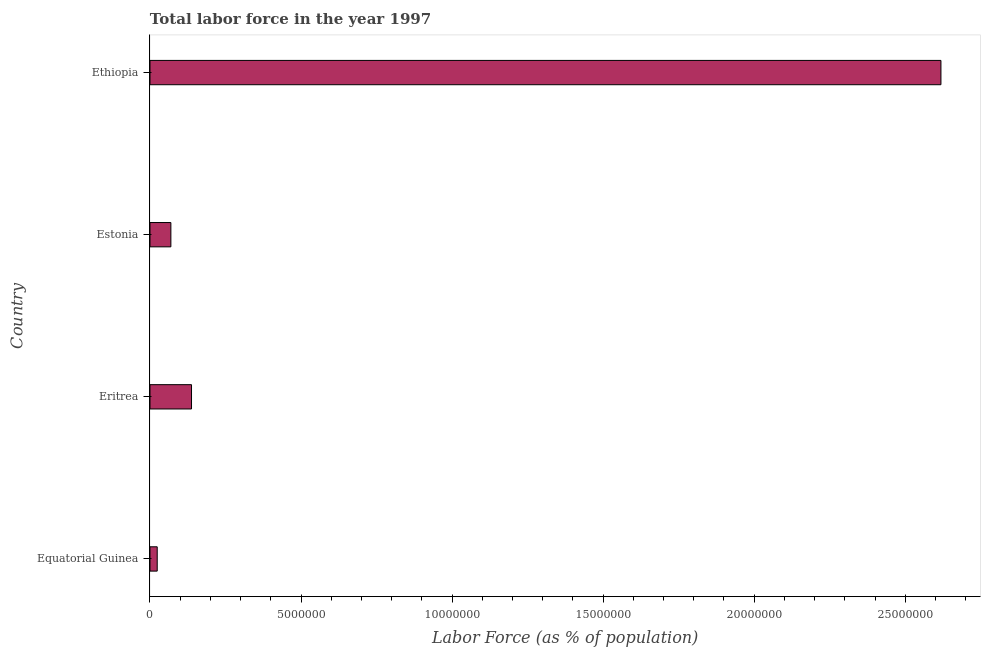Does the graph contain grids?
Ensure brevity in your answer.  No. What is the title of the graph?
Keep it short and to the point. Total labor force in the year 1997. What is the label or title of the X-axis?
Your answer should be very brief. Labor Force (as % of population). What is the label or title of the Y-axis?
Keep it short and to the point. Country. What is the total labor force in Eritrea?
Your answer should be compact. 1.37e+06. Across all countries, what is the maximum total labor force?
Ensure brevity in your answer.  2.62e+07. Across all countries, what is the minimum total labor force?
Keep it short and to the point. 2.39e+05. In which country was the total labor force maximum?
Ensure brevity in your answer.  Ethiopia. In which country was the total labor force minimum?
Offer a very short reply. Equatorial Guinea. What is the sum of the total labor force?
Provide a short and direct response. 2.85e+07. What is the difference between the total labor force in Equatorial Guinea and Estonia?
Ensure brevity in your answer.  -4.52e+05. What is the average total labor force per country?
Your answer should be compact. 7.12e+06. What is the median total labor force?
Your answer should be very brief. 1.03e+06. In how many countries, is the total labor force greater than 1000000 %?
Ensure brevity in your answer.  2. What is the ratio of the total labor force in Equatorial Guinea to that in Ethiopia?
Make the answer very short. 0.01. Is the difference between the total labor force in Equatorial Guinea and Ethiopia greater than the difference between any two countries?
Make the answer very short. Yes. What is the difference between the highest and the second highest total labor force?
Provide a succinct answer. 2.48e+07. Is the sum of the total labor force in Equatorial Guinea and Estonia greater than the maximum total labor force across all countries?
Offer a terse response. No. What is the difference between the highest and the lowest total labor force?
Your answer should be very brief. 2.59e+07. Are all the bars in the graph horizontal?
Provide a short and direct response. Yes. How many countries are there in the graph?
Give a very brief answer. 4. What is the difference between two consecutive major ticks on the X-axis?
Your answer should be compact. 5.00e+06. Are the values on the major ticks of X-axis written in scientific E-notation?
Make the answer very short. No. What is the Labor Force (as % of population) of Equatorial Guinea?
Provide a short and direct response. 2.39e+05. What is the Labor Force (as % of population) in Eritrea?
Ensure brevity in your answer.  1.37e+06. What is the Labor Force (as % of population) in Estonia?
Offer a very short reply. 6.91e+05. What is the Labor Force (as % of population) of Ethiopia?
Your response must be concise. 2.62e+07. What is the difference between the Labor Force (as % of population) in Equatorial Guinea and Eritrea?
Ensure brevity in your answer.  -1.14e+06. What is the difference between the Labor Force (as % of population) in Equatorial Guinea and Estonia?
Keep it short and to the point. -4.52e+05. What is the difference between the Labor Force (as % of population) in Equatorial Guinea and Ethiopia?
Give a very brief answer. -2.59e+07. What is the difference between the Labor Force (as % of population) in Eritrea and Estonia?
Give a very brief answer. 6.83e+05. What is the difference between the Labor Force (as % of population) in Eritrea and Ethiopia?
Give a very brief answer. -2.48e+07. What is the difference between the Labor Force (as % of population) in Estonia and Ethiopia?
Your answer should be compact. -2.55e+07. What is the ratio of the Labor Force (as % of population) in Equatorial Guinea to that in Eritrea?
Your response must be concise. 0.17. What is the ratio of the Labor Force (as % of population) in Equatorial Guinea to that in Estonia?
Give a very brief answer. 0.35. What is the ratio of the Labor Force (as % of population) in Equatorial Guinea to that in Ethiopia?
Give a very brief answer. 0.01. What is the ratio of the Labor Force (as % of population) in Eritrea to that in Estonia?
Provide a succinct answer. 1.99. What is the ratio of the Labor Force (as % of population) in Eritrea to that in Ethiopia?
Make the answer very short. 0.05. What is the ratio of the Labor Force (as % of population) in Estonia to that in Ethiopia?
Provide a succinct answer. 0.03. 